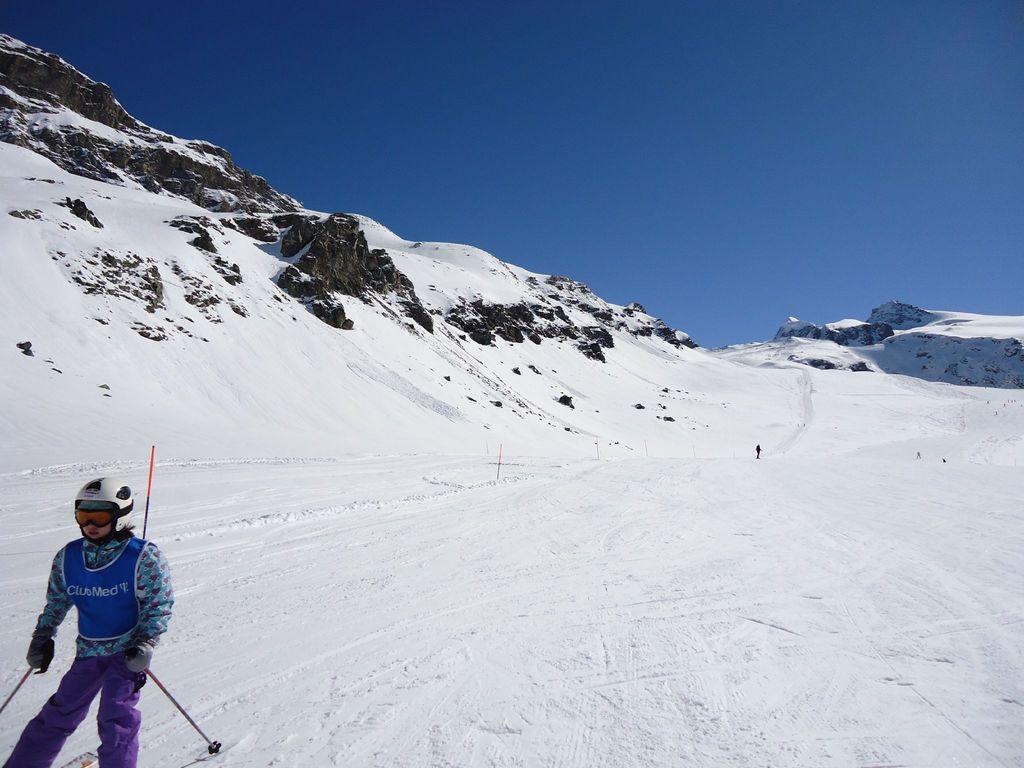Who or what is on the left side of the image? There is a person on the left side of the image. What is the terrain like in the image? There is snow on the hill in the image. What is visible at the top of the image? The sky is visible at the top of the image. How many rabbits can be seen playing with toys in the image? There are no rabbits or toys present in the image. What is the person's wish in the image? There is no information about the person's wish in the image. 